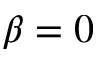Convert formula to latex. <formula><loc_0><loc_0><loc_500><loc_500>\beta = 0</formula> 